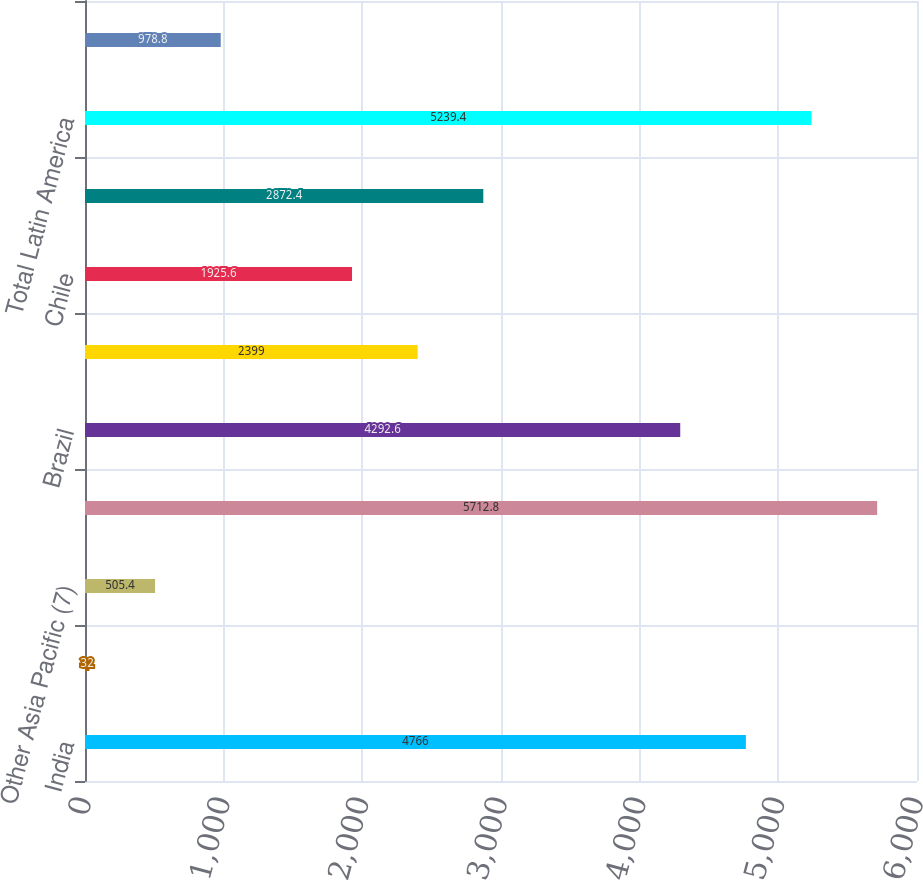<chart> <loc_0><loc_0><loc_500><loc_500><bar_chart><fcel>India<fcel>Taiwan<fcel>Other Asia Pacific (7)<fcel>Total Asia Pacific<fcel>Brazil<fcel>Mexico<fcel>Chile<fcel>Other Latin America (7)<fcel>Total Latin America<fcel>Other Middle East and Africa<nl><fcel>4766<fcel>32<fcel>505.4<fcel>5712.8<fcel>4292.6<fcel>2399<fcel>1925.6<fcel>2872.4<fcel>5239.4<fcel>978.8<nl></chart> 